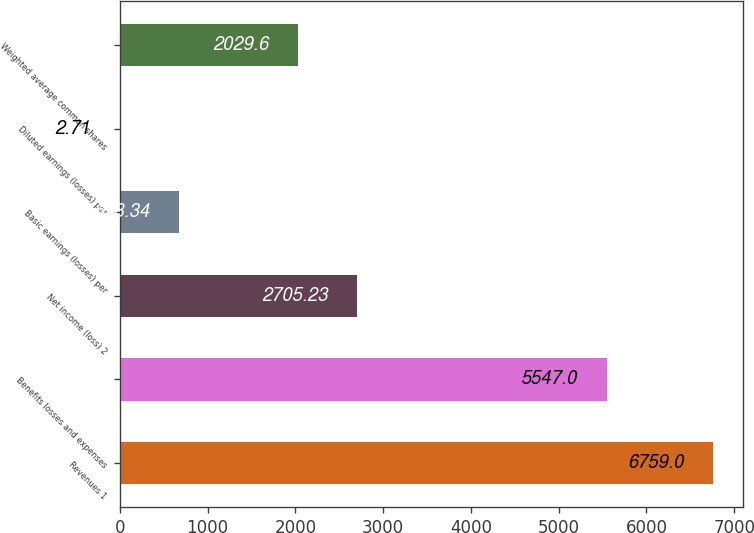<chart> <loc_0><loc_0><loc_500><loc_500><bar_chart><fcel>Revenues 1<fcel>Benefits losses and expenses<fcel>Net income (loss) 2<fcel>Basic earnings (losses) per<fcel>Diluted earnings (losses) per<fcel>Weighted average common shares<nl><fcel>6759<fcel>5547<fcel>2705.23<fcel>678.34<fcel>2.71<fcel>2029.6<nl></chart> 